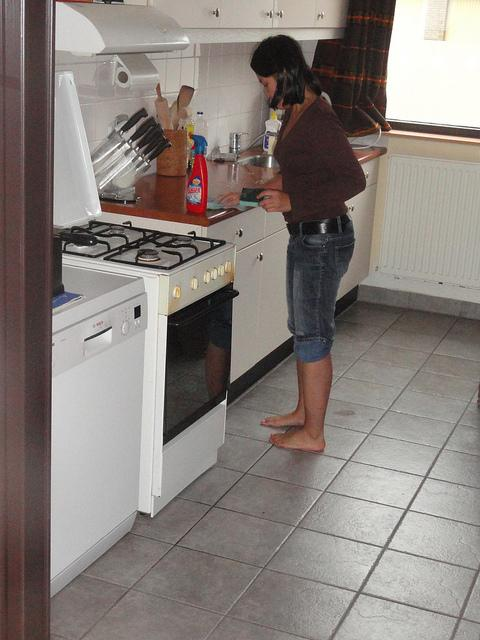How are dishes cleaned here?

Choices:
A) they aren't
B) dishwashing machine
C) sponged
D) air washed dishwashing machine 